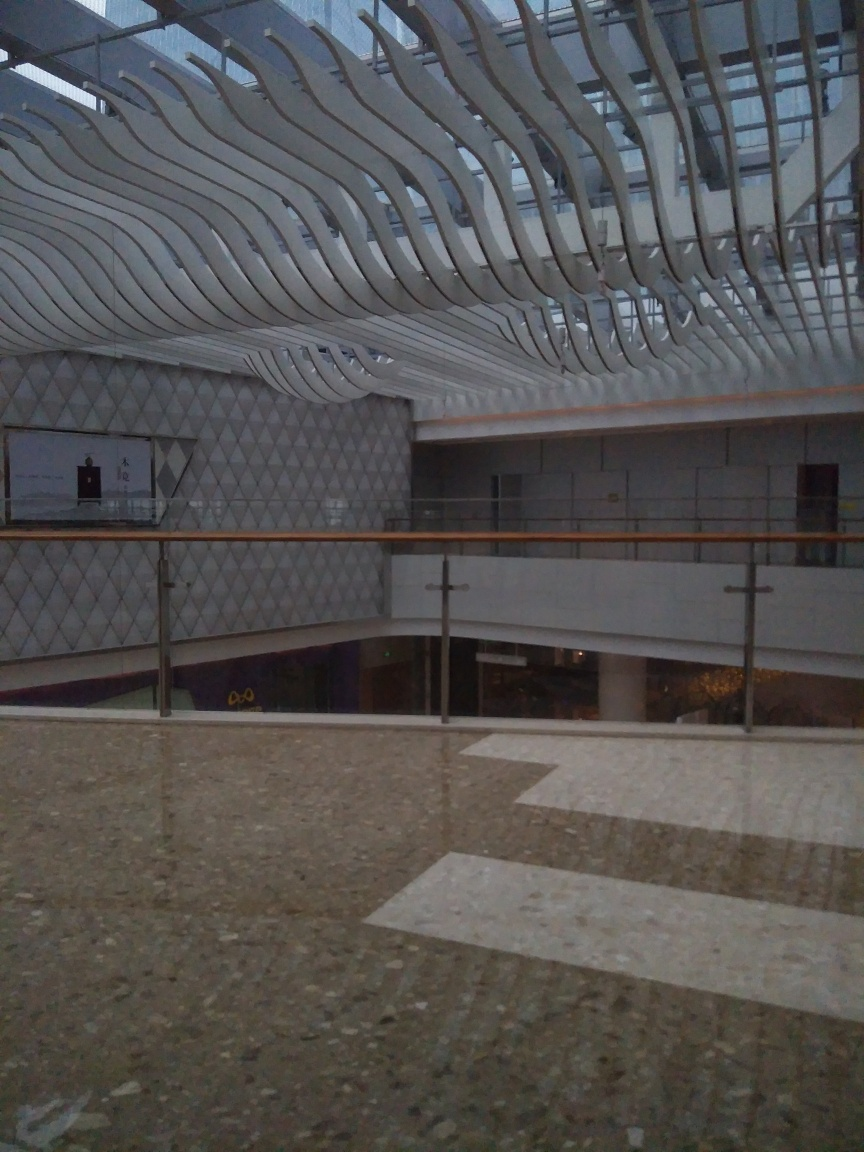Can you tell me what this structure is used for? This structure appears to be an interior space of a modern building, likely a public or commercial space given the architectural design and materials used. The curved overhead features could be part of an artistic ceiling installation or serve a functional purpose like aiding in acoustics or airflow. The open areas suggest a gathering or transit space, possibly a lobby, atrium, or part of a shopping or cultural center. 